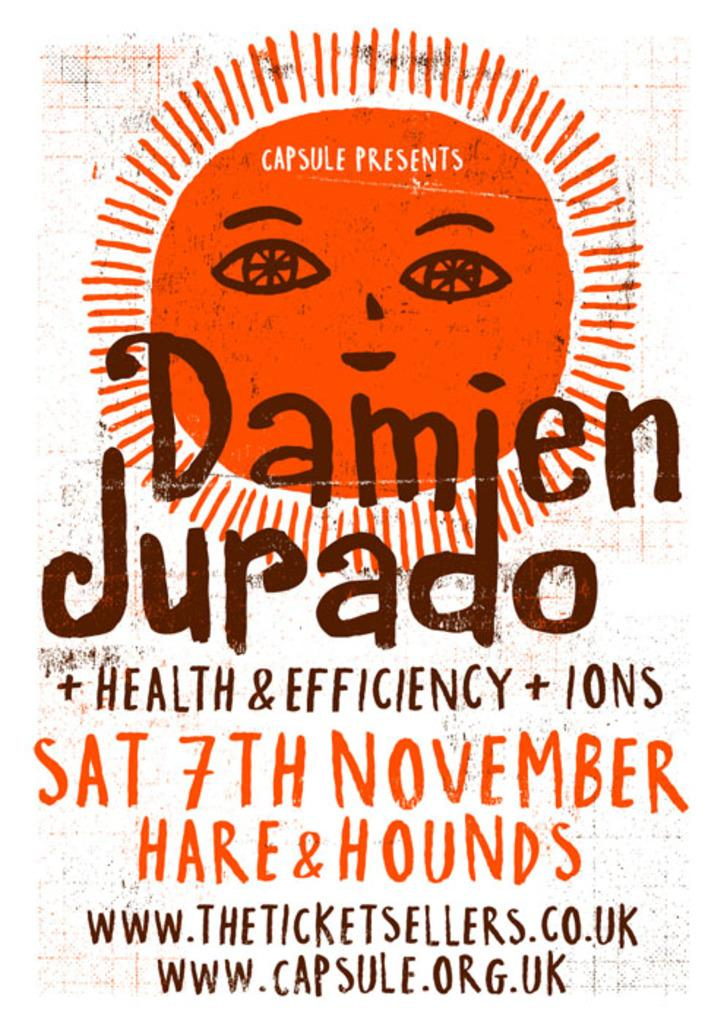<image>
Describe the image concisely. a poster for health and efficiency by capsule 